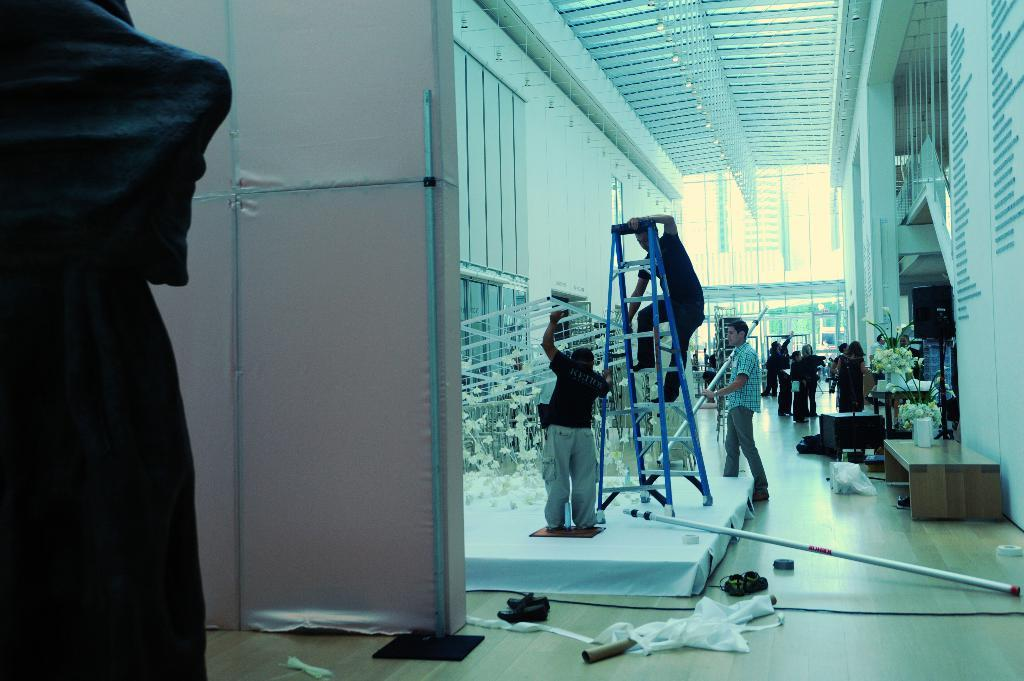What type of location is depicted in the image? The image shows an inside view of a building. What structural element can be seen in the image? There is a wall visible in the image. What part of the building is visible above the people? The ceiling is present in the image. How many people are in the image? There are people in the image. What decorative elements are present in the image? There are flowers in the image. What objects are used for specific purposes in the image? There are equipment visible in the image. What surface is under the people's feet? The floor is visible in the image. What type of caption is written on the wall in the image? There is no caption written on the wall in the image; it is a plain wall. How does the sand contribute to the overall aesthetic of the image? There is no sand present in the image; it is an indoor setting with a floor, not sand. 